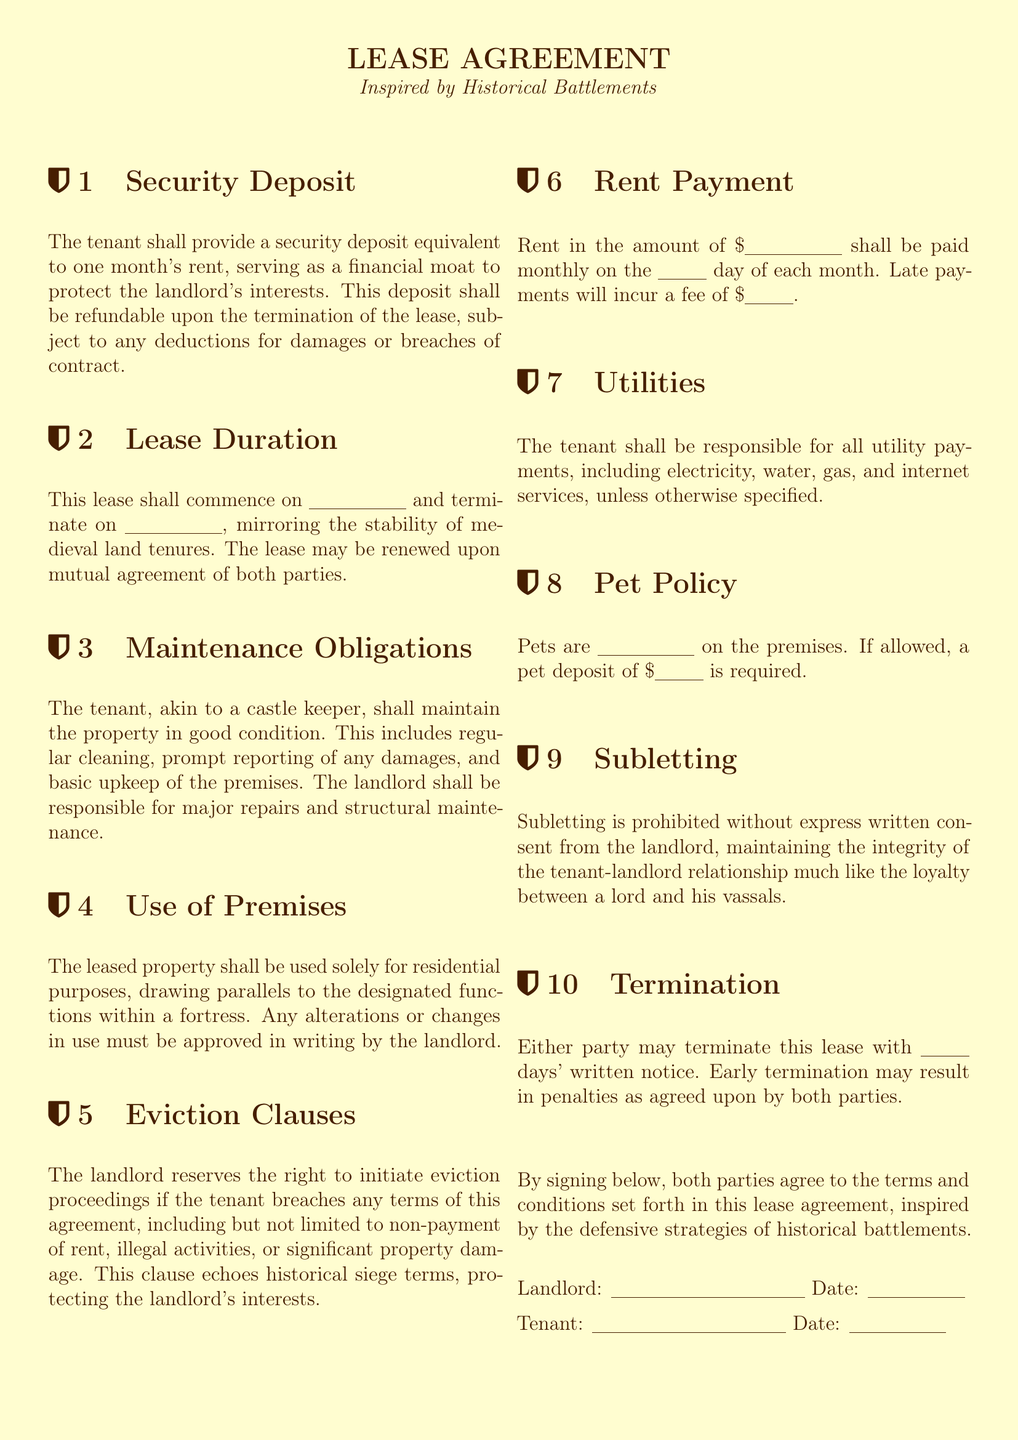What is the security deposit amount? The security deposit is specified as equivalent to one month's rent, which is mentioned in the Security Deposit section.
Answer: one month's rent What is the lease commencement date? The lease commencement date is left blank for the tenant to fill in, as indicated in the Lease Duration section.
Answer: \underline{\hspace{2cm}} Who is responsible for major repairs? The landlord is responsible for major repairs and structural maintenance as stated in the Maintenance Obligations section.
Answer: landlord What is the pet policy? The pet policy is specified in the Pet Policy section, which indicates whether pets are allowed or not.
Answer: \underline{\hspace{2cm}} How many days' notice is required for termination? The termination notice period is stated in the Termination section, which specifies the number of days required for written notice.
Answer: \underline{\hspace{1cm}} What happens if rent is paid late? The consequences of late payment are outlined in the Rent Payment section, which mentions a fee for late payments.
Answer: \$\underline{\hspace{1cm}} What is the tenant's obligation regarding the use of premises? The tenant can use the premises only for specific purposes as mentioned in the Use of Premises section.
Answer: residential purposes Is subletting allowed? The subletting policy is clearly outlined in the Subletting section of the document.
Answer: prohibited 